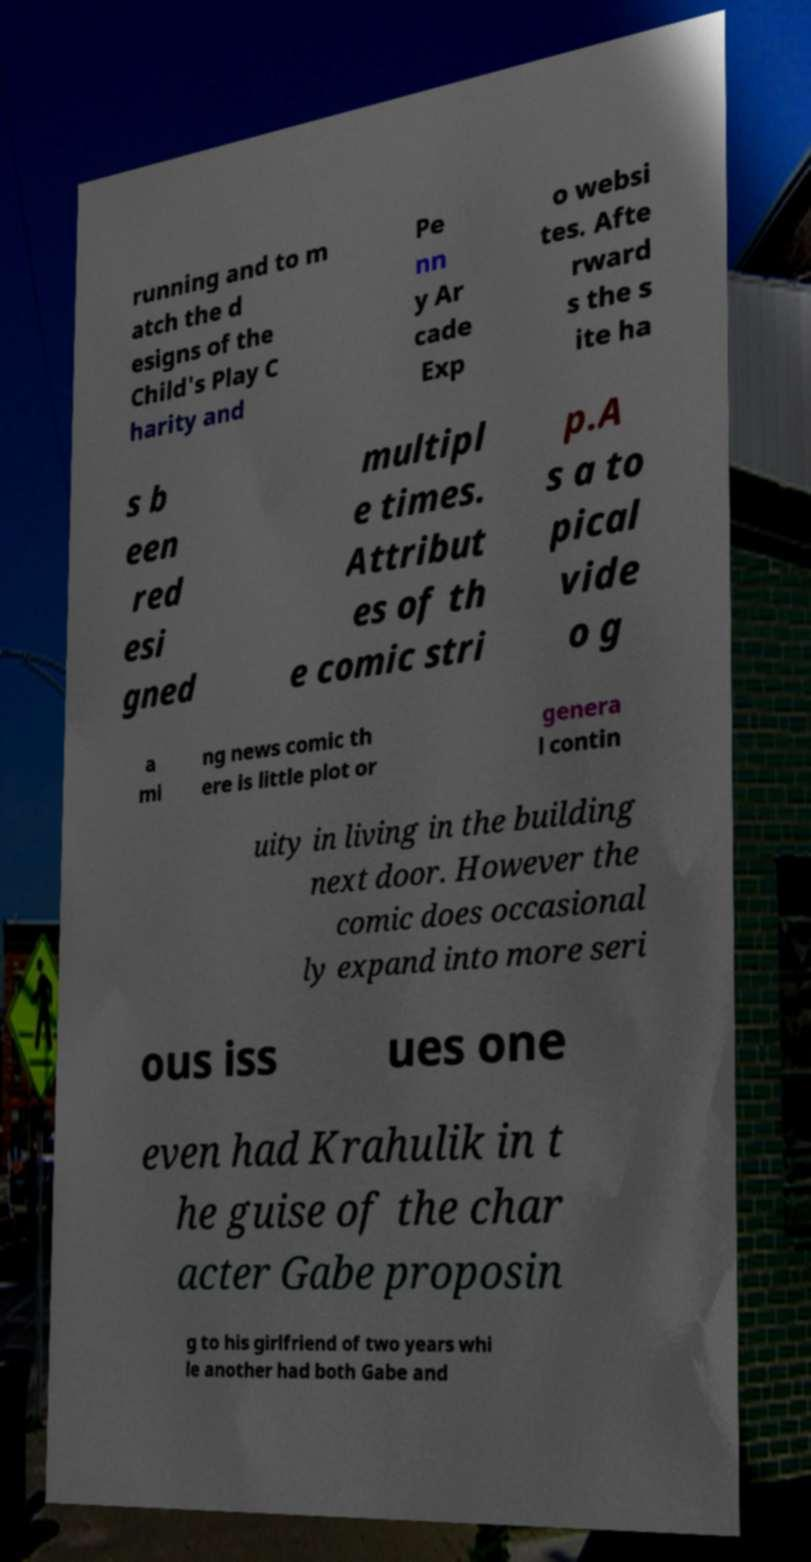Can you read and provide the text displayed in the image?This photo seems to have some interesting text. Can you extract and type it out for me? running and to m atch the d esigns of the Child's Play C harity and Pe nn y Ar cade Exp o websi tes. Afte rward s the s ite ha s b een red esi gned multipl e times. Attribut es of th e comic stri p.A s a to pical vide o g a mi ng news comic th ere is little plot or genera l contin uity in living in the building next door. However the comic does occasional ly expand into more seri ous iss ues one even had Krahulik in t he guise of the char acter Gabe proposin g to his girlfriend of two years whi le another had both Gabe and 